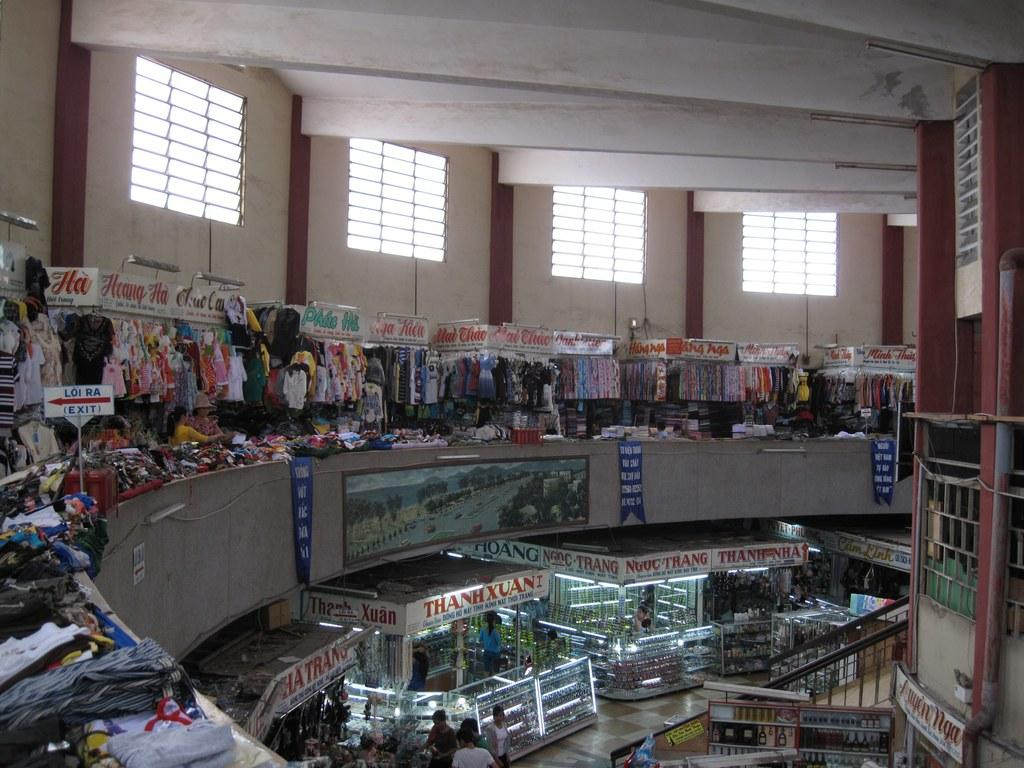Provide a one-sentence caption for the provided image. Store mall with a stand that says ThanhXuan. 